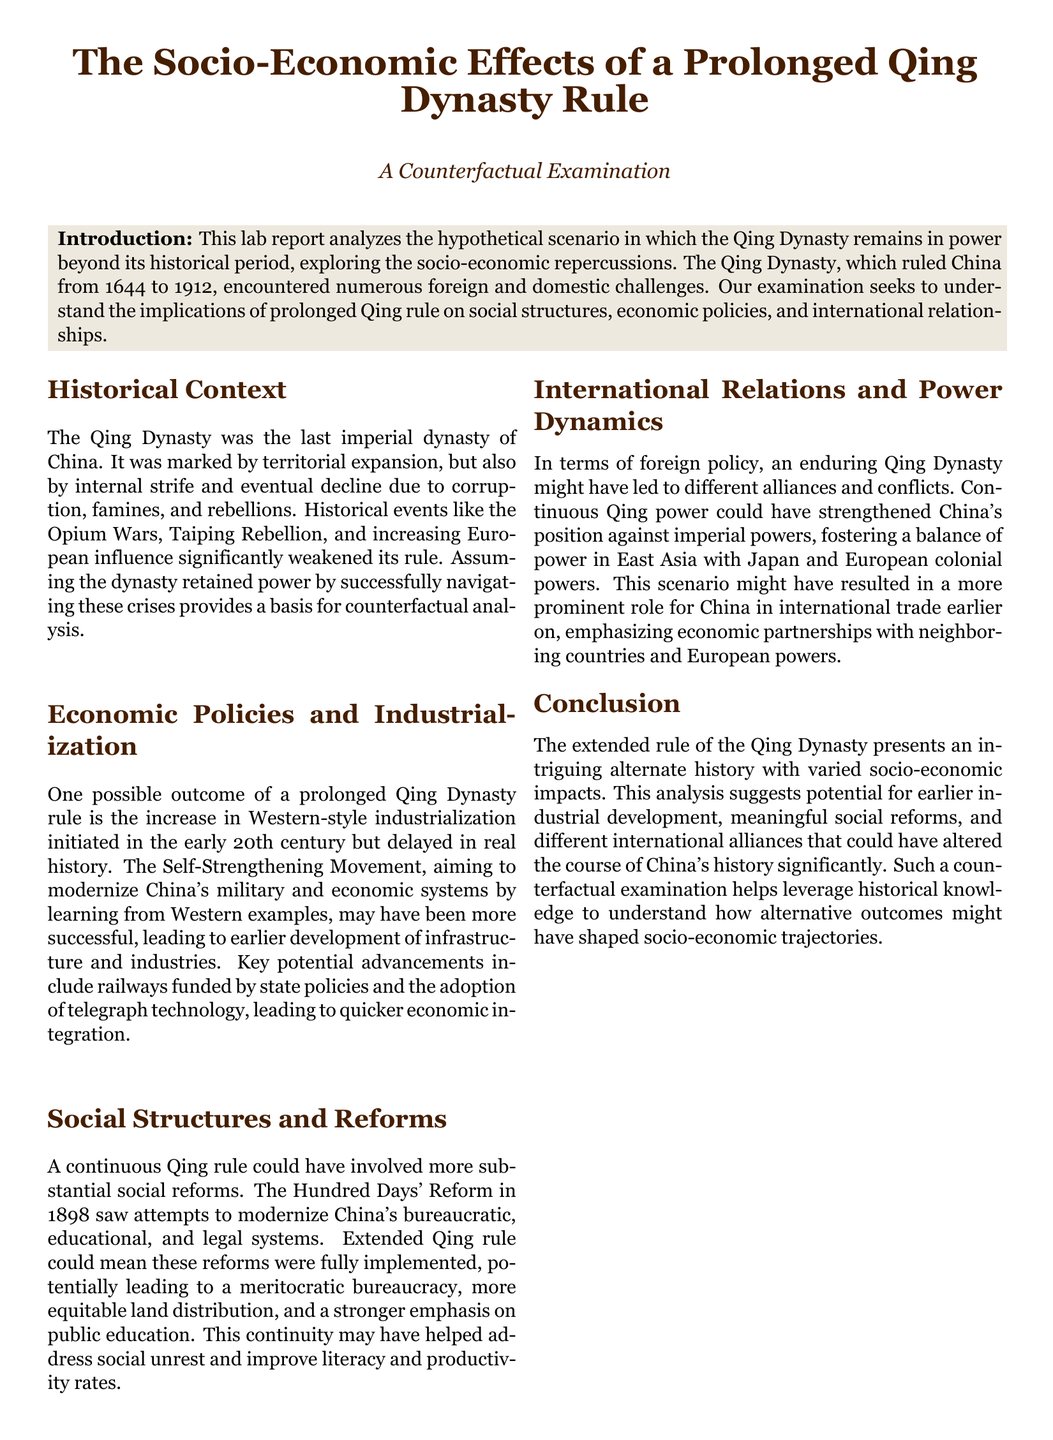What was the last imperial dynasty of China? The document states that the Qing Dynasty was the last imperial dynasty of China.
Answer: Qing Dynasty What years did the Qing Dynasty rule? The ruling years of the Qing Dynasty mentioned in the document are from 1644 to 1912.
Answer: 1644 to 1912 What major reform attempt is noted in 1898? The document refers to the Hundred Days' Reform as the major reform attempt in 1898.
Answer: Hundred Days' Reform What technological advancement could have been adopted earlier? The document suggests that telegraph technology could have been adopted earlier as a result of prolonged Qing rule.
Answer: Telegraph technology What movement aimed to modernize China's military and economic systems? The Self-Strengthening Movement is identified in the document as the initiative aimed at modernization.
Answer: Self-Strengthening Movement How could prolonged Qing rule impact social structures? The document mentions that more substantial social reforms could evolve from an extended Qing rule.
Answer: More substantial social reforms What does the report suggest about international trade? The document indicates that a continuous Qing power might have resulted in a more prominent role for China in international trade.
Answer: More prominent role for China in international trade What is the primary focus of the counterfactual examination? The focus is on understanding the implications of prolonged Qing rule on socio-economic repercussions.
Answer: Socio-economic repercussions 